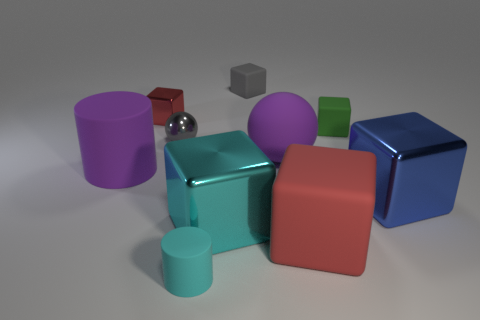Subtract all tiny red blocks. How many blocks are left? 5 Subtract all blue blocks. How many blocks are left? 5 Subtract all gray cubes. Subtract all cyan cylinders. How many cubes are left? 5 Subtract all balls. How many objects are left? 8 Add 6 red metal things. How many red metal things exist? 7 Subtract 0 cyan balls. How many objects are left? 10 Subtract all green rubber cylinders. Subtract all large rubber cylinders. How many objects are left? 9 Add 9 tiny gray rubber blocks. How many tiny gray rubber blocks are left? 10 